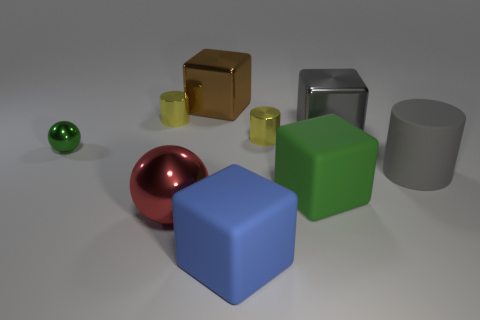Is there any other thing that has the same shape as the red thing?
Your answer should be very brief. Yes. The tiny metal object behind the yellow metal cylinder that is in front of the big gray metal thing is what color?
Ensure brevity in your answer.  Yellow. What number of large gray rubber objects are there?
Ensure brevity in your answer.  1. What number of matte things are either small yellow objects or tiny balls?
Your answer should be compact. 0. How many small shiny cylinders have the same color as the tiny shiny sphere?
Offer a terse response. 0. What material is the big cube in front of the big metal object in front of the green metal ball made of?
Keep it short and to the point. Rubber. What size is the gray metallic thing?
Offer a terse response. Large. How many metallic cubes have the same size as the red metal object?
Provide a succinct answer. 2. What number of gray rubber things have the same shape as the blue thing?
Your response must be concise. 0. Are there an equal number of large green matte things in front of the big blue rubber thing and blue things?
Your answer should be very brief. No. 